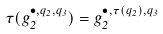<formula> <loc_0><loc_0><loc_500><loc_500>\tau ( g _ { 2 } ^ { \bullet , q _ { 2 } , q _ { 3 } } ) = g _ { 2 } ^ { \bullet , \tau ( q _ { 2 } ) , q _ { 3 } }</formula> 